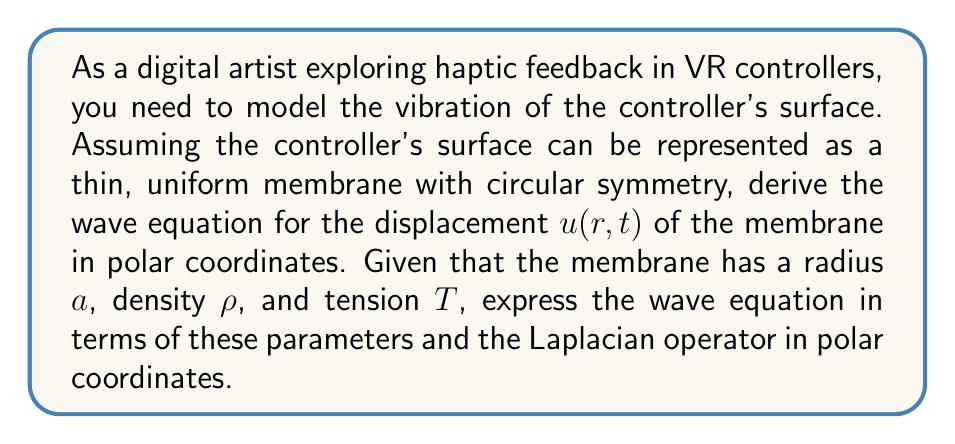Could you help me with this problem? To derive the wave equation for the haptic feedback in a VR controller, we'll follow these steps:

1) The general form of the wave equation in 2D is:

   $$\frac{\partial^2 u}{\partial t^2} = c^2 \nabla^2 u$$

   where $c$ is the wave speed and $\nabla^2$ is the Laplacian operator.

2) For a circular membrane, we use polar coordinates $(r,\theta)$. The Laplacian in polar coordinates is:

   $$\nabla^2 u = \frac{\partial^2 u}{\partial r^2} + \frac{1}{r}\frac{\partial u}{\partial r} + \frac{1}{r^2}\frac{\partial^2 u}{\partial \theta^2}$$

3) Assuming circular symmetry, the displacement $u$ doesn't depend on $\theta$, so $\frac{\partial^2 u}{\partial \theta^2} = 0$. The Laplacian simplifies to:

   $$\nabla^2 u = \frac{\partial^2 u}{\partial r^2} + \frac{1}{r}\frac{\partial u}{\partial r}$$

4) The wave speed $c$ for a membrane is given by:

   $$c = \sqrt{\frac{T}{\rho}}$$

   where $T$ is the tension and $\rho$ is the density of the membrane.

5) Substituting these into the wave equation:

   $$\frac{\partial^2 u}{\partial t^2} = \frac{T}{\rho} \left(\frac{\partial^2 u}{\partial r^2} + \frac{1}{r}\frac{\partial u}{\partial r}\right)$$

This is the wave equation for the displacement $u(r,t)$ of the VR controller's surface, modeled as a circular membrane with radius $a$, density $\rho$, and tension $T$.
Answer: $$\frac{\partial^2 u}{\partial t^2} = \frac{T}{\rho} \left(\frac{\partial^2 u}{\partial r^2} + \frac{1}{r}\frac{\partial u}{\partial r}\right)$$ 